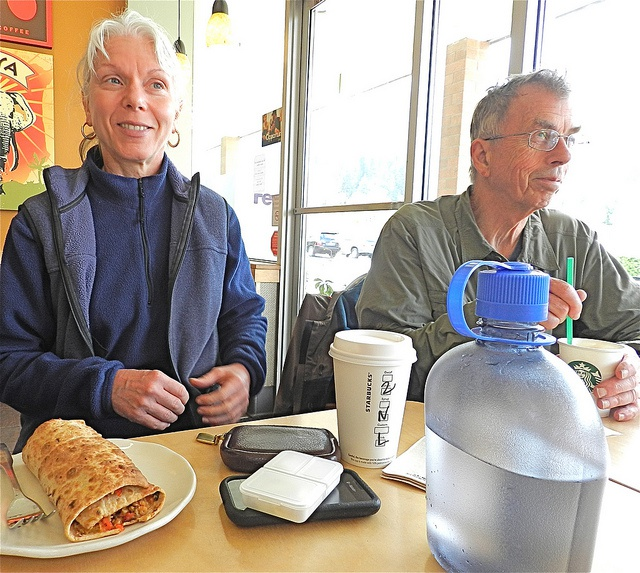Describe the objects in this image and their specific colors. I can see people in tan, black, and gray tones, bottle in tan, darkgray, lightgray, and gray tones, people in tan, gray, brown, white, and darkgray tones, dining table in tan and olive tones, and cup in tan and white tones in this image. 